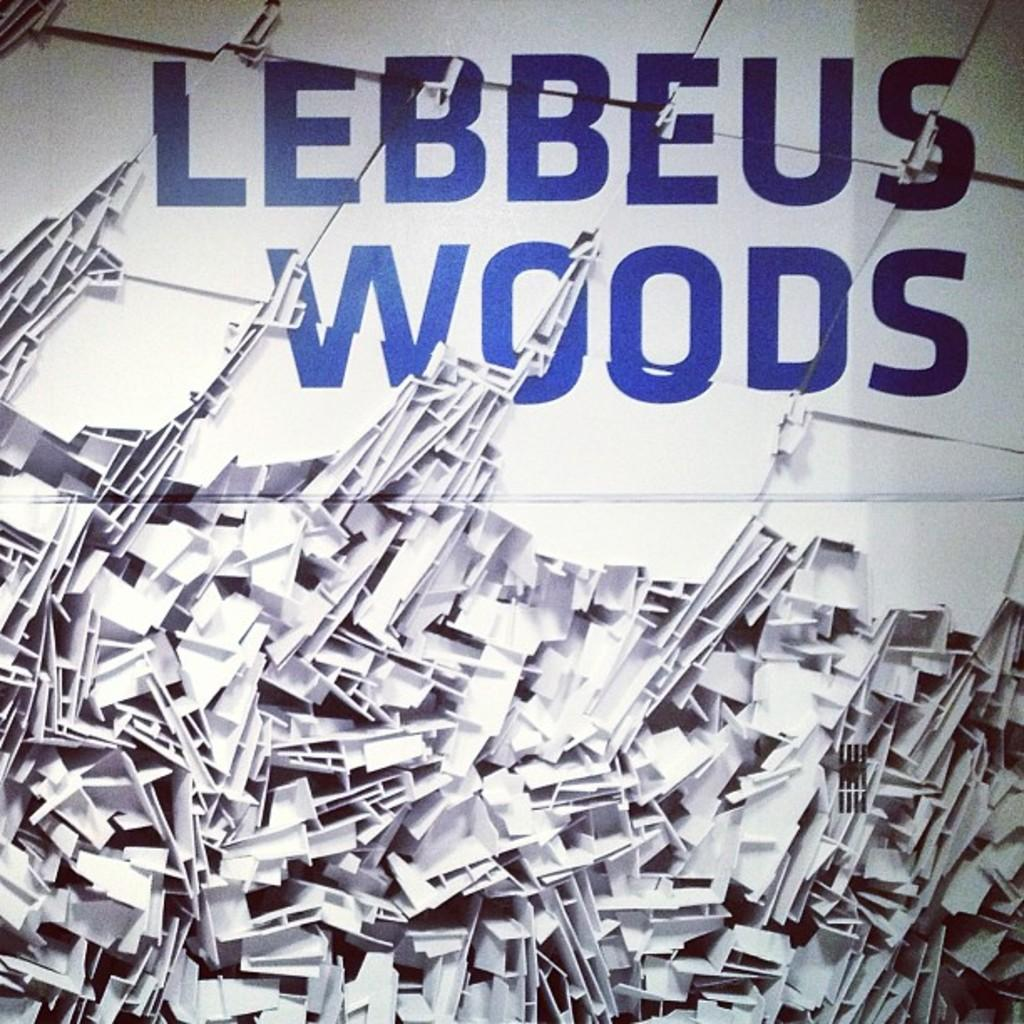<image>
Write a terse but informative summary of the picture. Blue lettering that says "Lebbeus Woods" on top of what looks like a bunch of pieces of folded paper. 